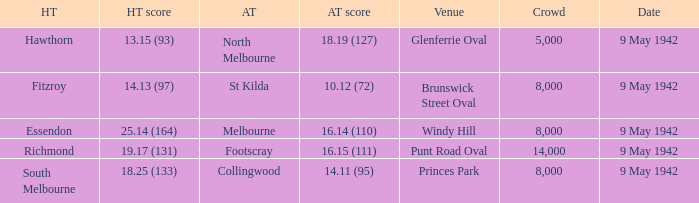How many people attended the game where Footscray was away? 14000.0. 